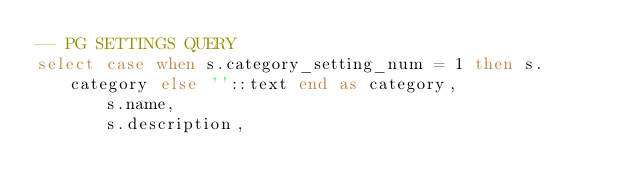Convert code to text. <code><loc_0><loc_0><loc_500><loc_500><_SQL_>-- PG SETTINGS QUERY
select case when s.category_setting_num = 1 then s.category else ''::text end as category,
       s.name,
       s.description,</code> 